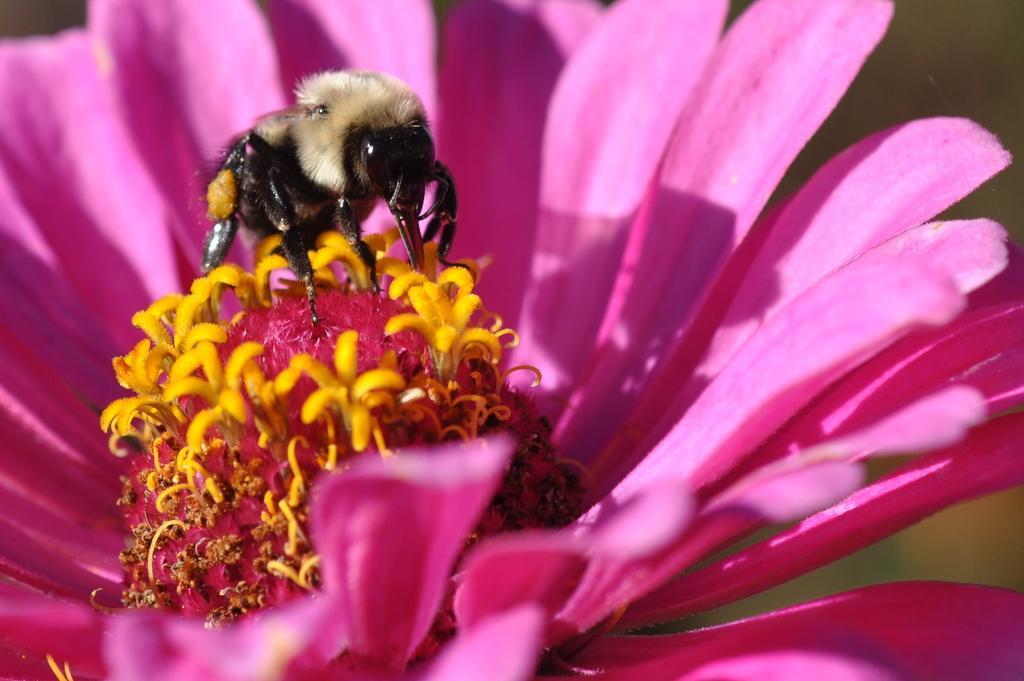Can you describe this image briefly? In this image I can see an insect which is cream, black and orange in color on a flower which is yellow and pink in color. I can see the blurry background. 